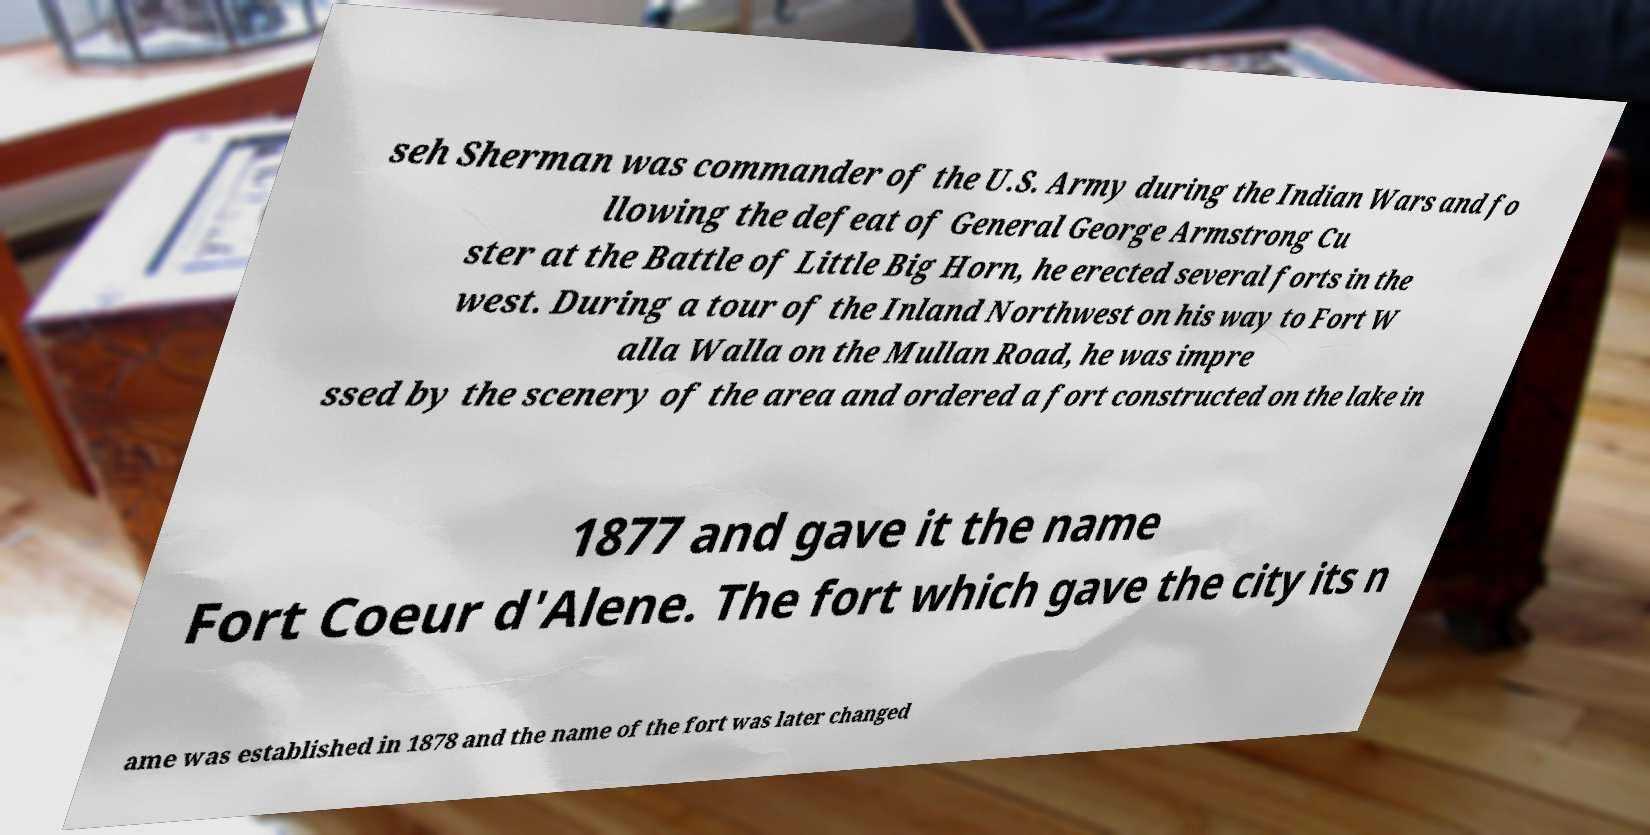Please read and relay the text visible in this image. What does it say? seh Sherman was commander of the U.S. Army during the Indian Wars and fo llowing the defeat of General George Armstrong Cu ster at the Battle of Little Big Horn, he erected several forts in the west. During a tour of the Inland Northwest on his way to Fort W alla Walla on the Mullan Road, he was impre ssed by the scenery of the area and ordered a fort constructed on the lake in 1877 and gave it the name Fort Coeur d'Alene. The fort which gave the city its n ame was established in 1878 and the name of the fort was later changed 